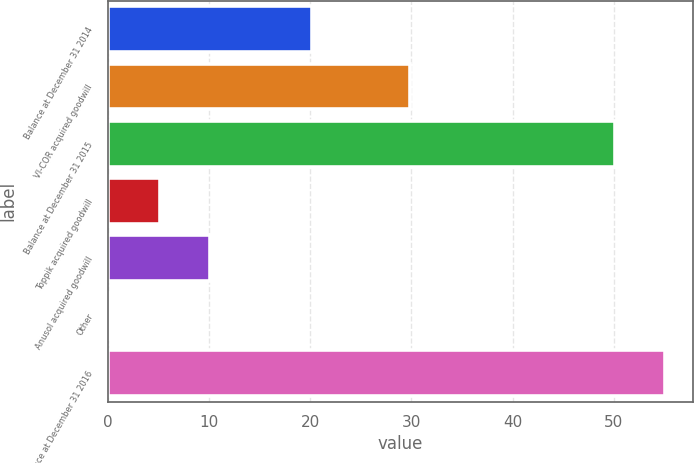Convert chart to OTSL. <chart><loc_0><loc_0><loc_500><loc_500><bar_chart><fcel>Balance at December 31 2014<fcel>VI-COR acquired goodwill<fcel>Balance at December 31 2015<fcel>Toppik acquired goodwill<fcel>Anusol acquired goodwill<fcel>Other<fcel>Balance at December 31 2016<nl><fcel>20.2<fcel>29.9<fcel>50.1<fcel>5.11<fcel>10.11<fcel>0.11<fcel>55.1<nl></chart> 